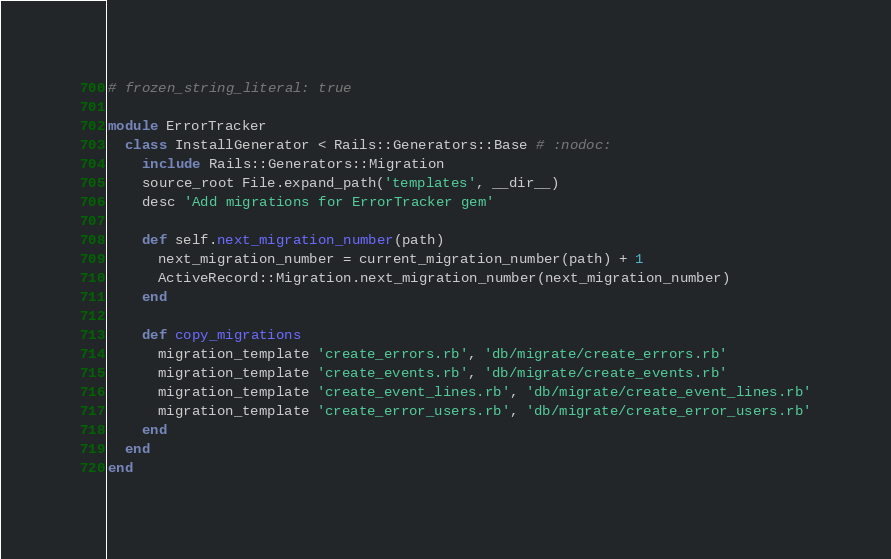Convert code to text. <code><loc_0><loc_0><loc_500><loc_500><_Ruby_># frozen_string_literal: true

module ErrorTracker
  class InstallGenerator < Rails::Generators::Base # :nodoc:
    include Rails::Generators::Migration
    source_root File.expand_path('templates', __dir__)
    desc 'Add migrations for ErrorTracker gem'

    def self.next_migration_number(path)
      next_migration_number = current_migration_number(path) + 1
      ActiveRecord::Migration.next_migration_number(next_migration_number)
    end

    def copy_migrations
      migration_template 'create_errors.rb', 'db/migrate/create_errors.rb'
      migration_template 'create_events.rb', 'db/migrate/create_events.rb'
      migration_template 'create_event_lines.rb', 'db/migrate/create_event_lines.rb'
      migration_template 'create_error_users.rb', 'db/migrate/create_error_users.rb'
    end
  end
end
</code> 